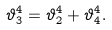Convert formula to latex. <formula><loc_0><loc_0><loc_500><loc_500>\vartheta _ { 3 } ^ { 4 } = \vartheta _ { 2 } ^ { 4 } + \vartheta _ { 4 } ^ { 4 } .</formula> 